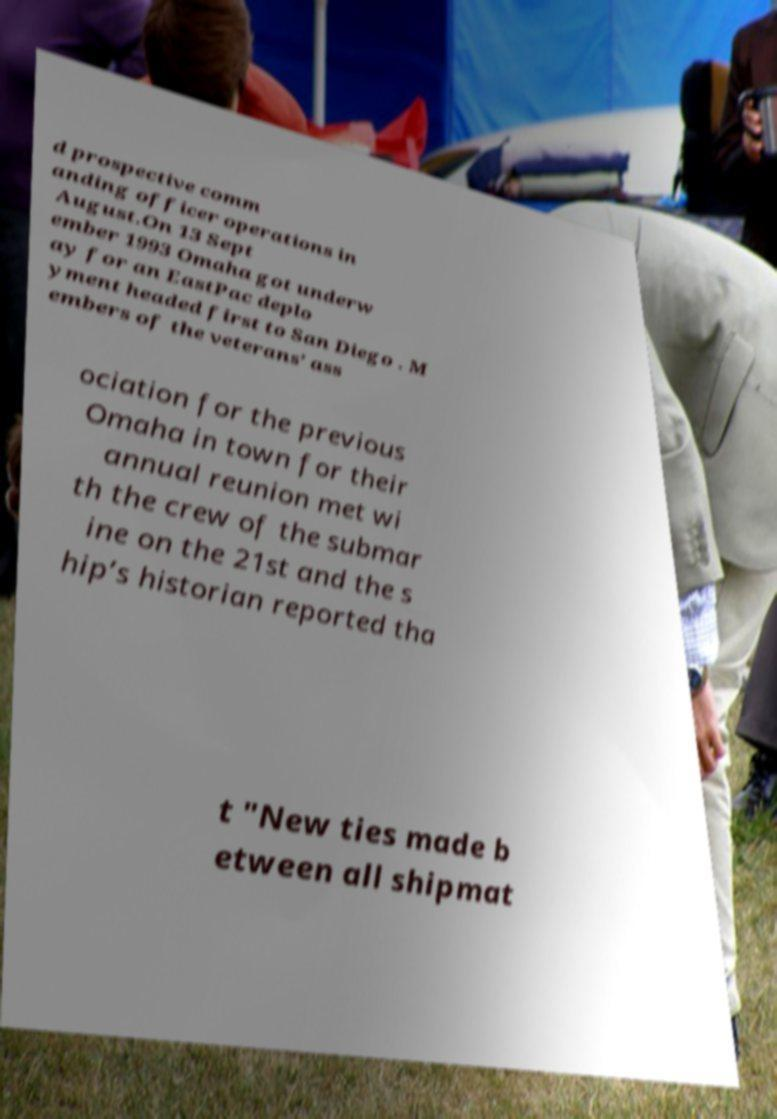What messages or text are displayed in this image? I need them in a readable, typed format. d prospective comm anding officer operations in August.On 13 Sept ember 1993 Omaha got underw ay for an EastPac deplo yment headed first to San Diego . M embers of the veterans’ ass ociation for the previous Omaha in town for their annual reunion met wi th the crew of the submar ine on the 21st and the s hip’s historian reported tha t "New ties made b etween all shipmat 